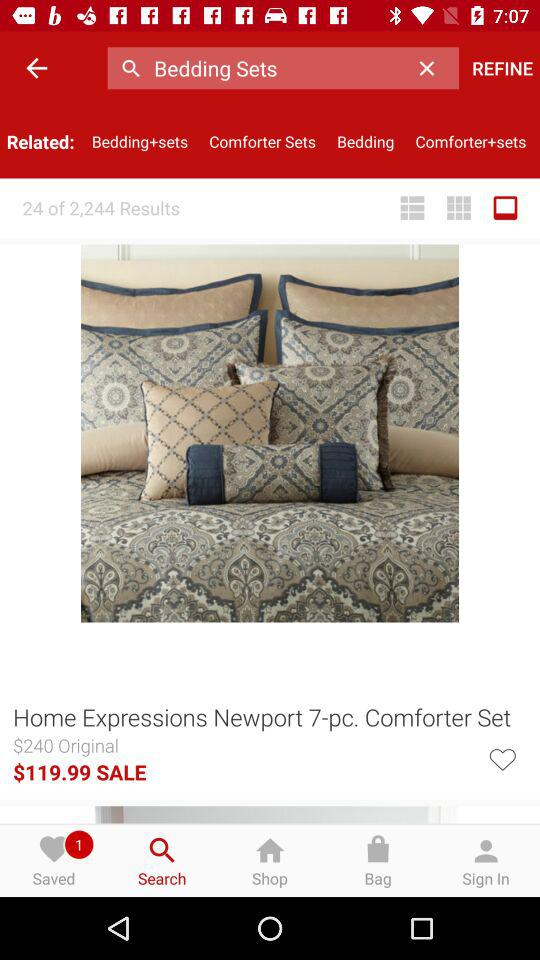What is the original price of the comforter set? The original price is $240. 